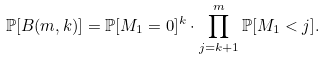<formula> <loc_0><loc_0><loc_500><loc_500>\mathbb { P } [ B ( m , k ) ] = \mathbb { P } [ M _ { 1 } = 0 ] ^ { k } \cdot \prod _ { j = k + 1 } ^ { m } \mathbb { P } [ M _ { 1 } < j ] .</formula> 